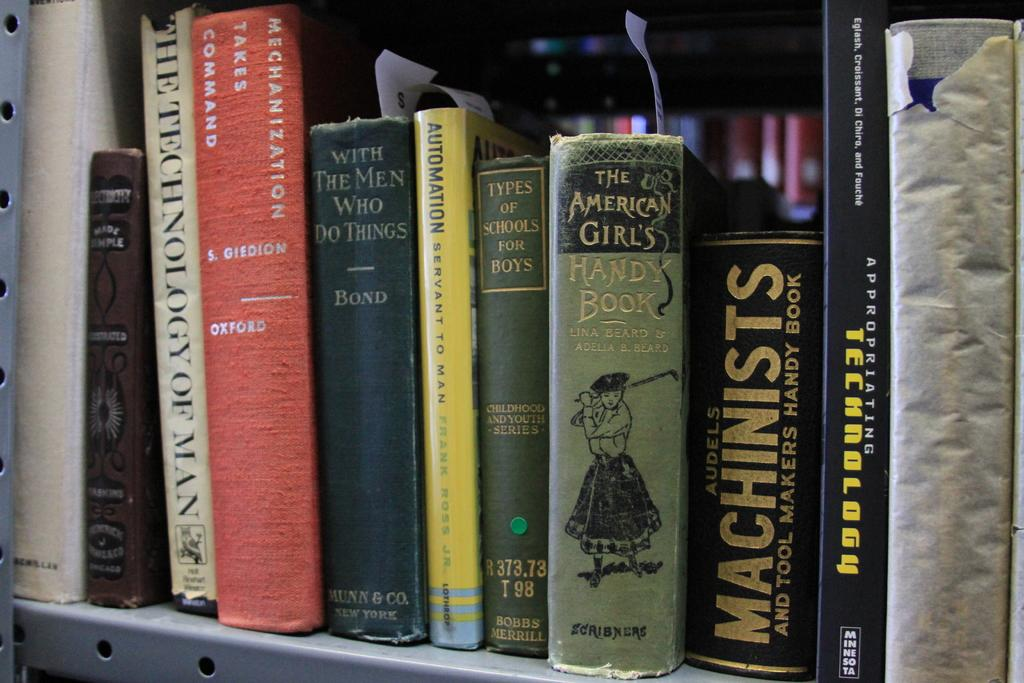<image>
Render a clear and concise summary of the photo. A collection of books on a shelf with one titled American Girls Handbook. 